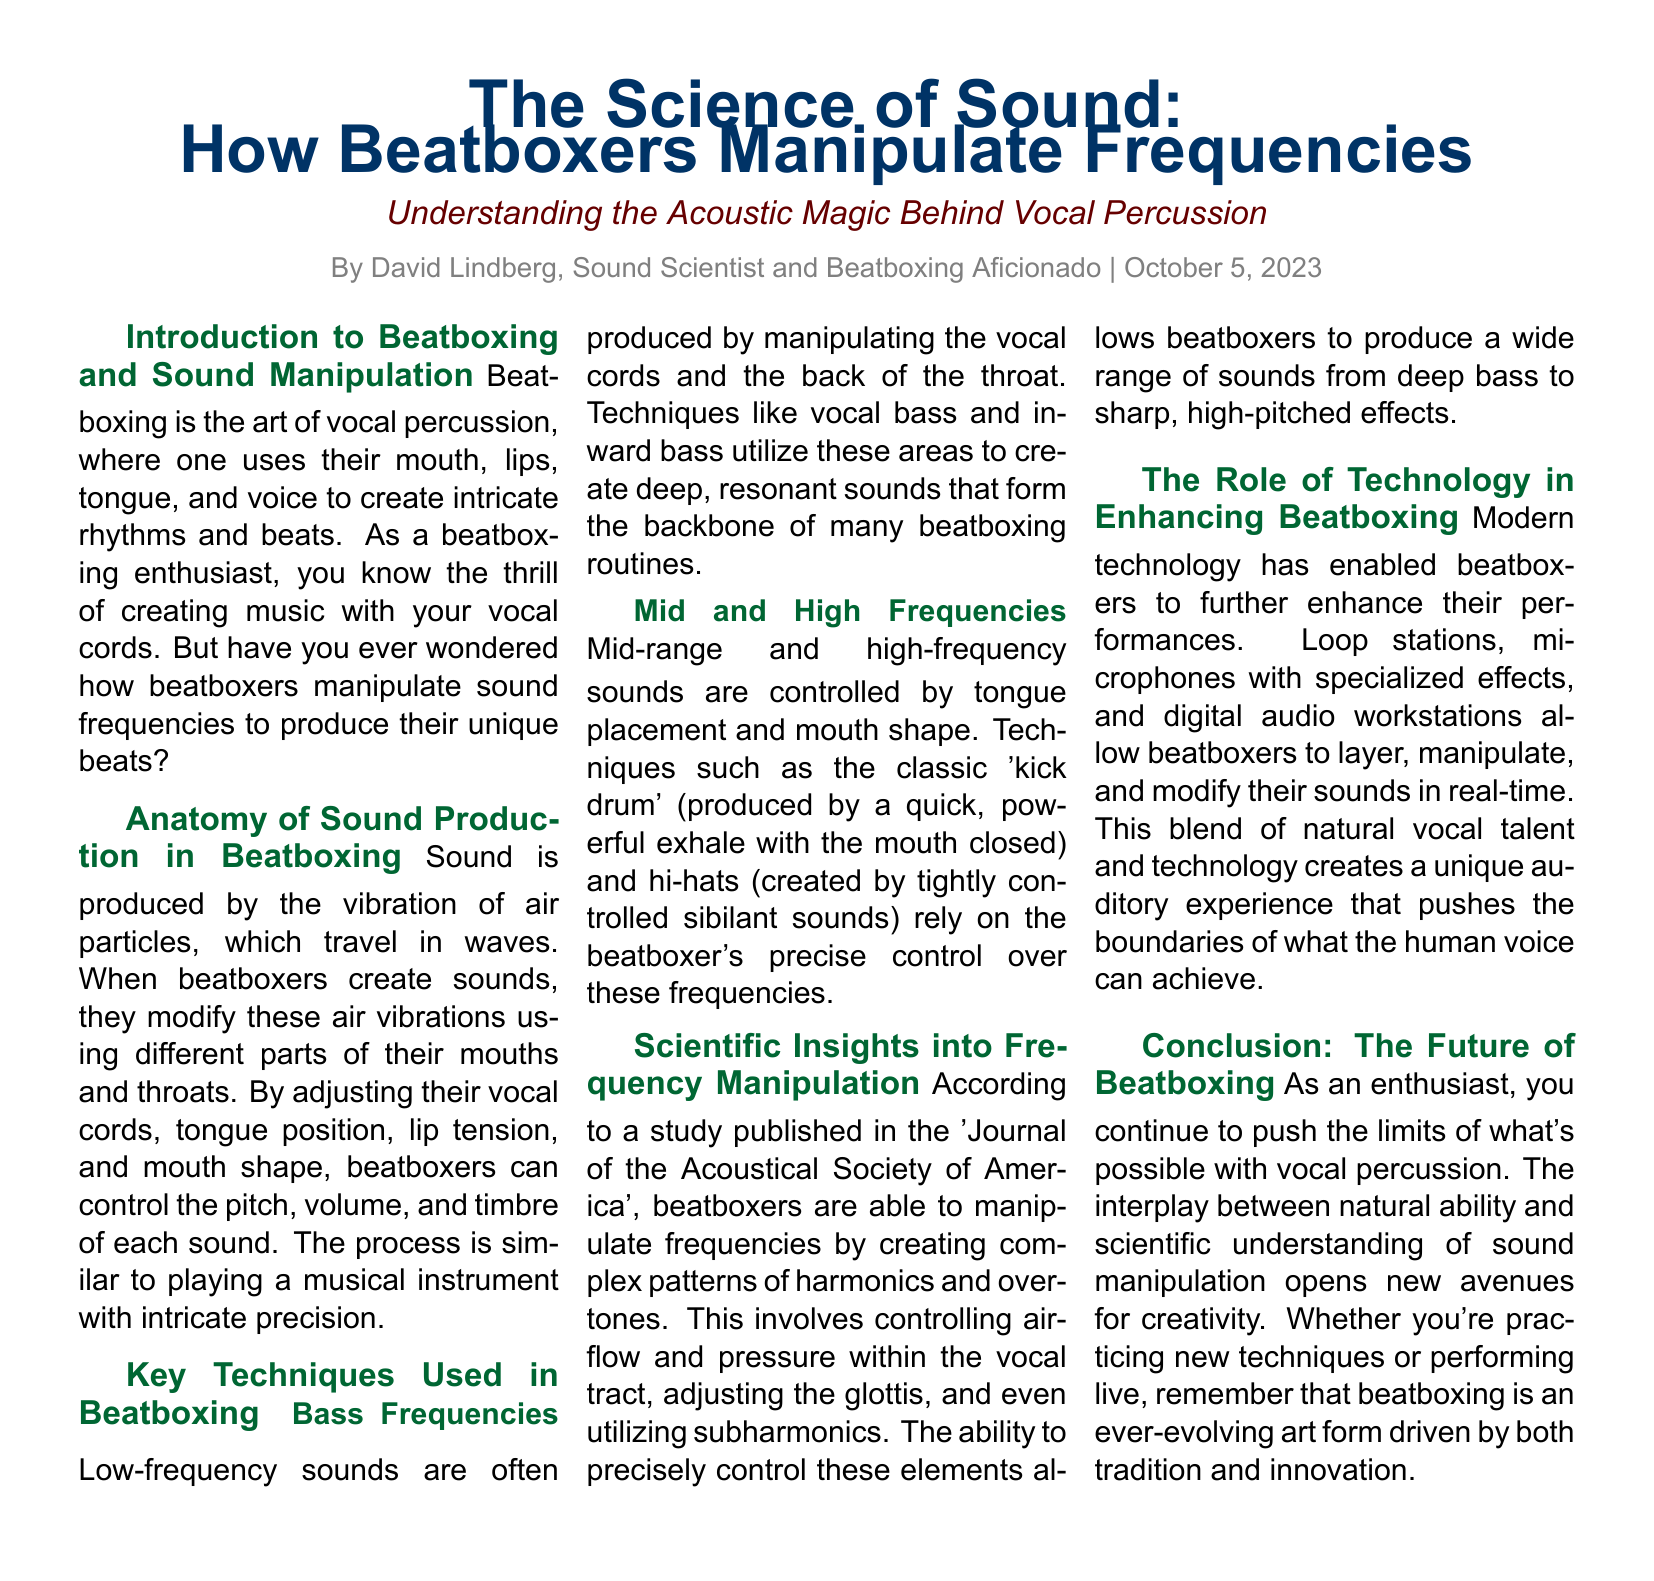What is the title of the article? The title is presented prominently at the top of the document, providing the main focus of the piece.
Answer: The Science of Sound: How Beatboxers Manipulate Frequencies Who is the author of the article? The author's name is mentioned below the headline, indicating who wrote the piece.
Answer: David Lindberg What date was the article published? The publication date is included alongside the author's name, noting when the article was released.
Answer: October 5, 2023 What is the main method of sound production described in the document? The document outlines that sound production in beatboxing involves specific actions related to the mouth and throat.
Answer: Vibration of air particles What technique is used to produce low-frequency sounds? The document discusses specific techniques for creating deep sounds, categorizing them under low-frequency techniques.
Answer: Vocal bass Which journal is mentioned in relation to frequency manipulation studies? The document references a specific scholarly publication that provides insights into beatboxing techniques.
Answer: Journal of the Acoustical Society of America How does modern technology influence beatboxing? The article explains that technology plays a significant role in enhancing the capabilities of beatboxers during performances.
Answer: Enhances performances What aspect of beatboxing is emphasized at its conclusion? The conclusion reflects on the ongoing developments and creativity within the art form of beatboxing.
Answer: Evolution of the art form 